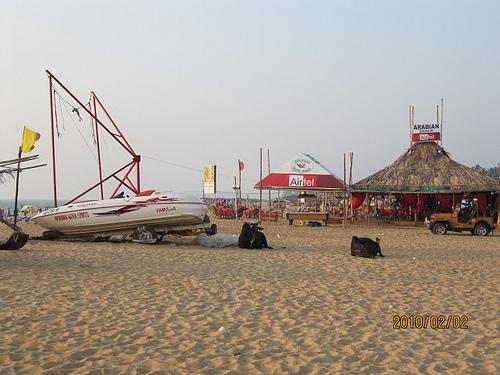Are the businesses busy?
Keep it brief. No. How many cars are there?
Keep it brief. 1. Is this a port?
Keep it brief. No. 